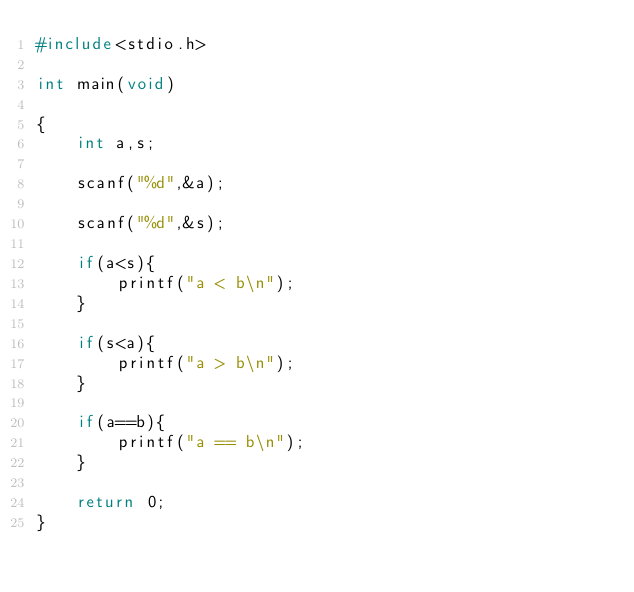Convert code to text. <code><loc_0><loc_0><loc_500><loc_500><_C_>#include<stdio.h>

int main(void)

{
    int a,s;
    
    scanf("%d",&a);
    
    scanf("%d",&s);
    
    if(a<s){
        printf("a < b\n");
    }
    
    if(s<a){
        printf("a > b\n");
    }
    
    if(a==b){
        printf("a == b\n");
    }

    return 0;
}
</code> 